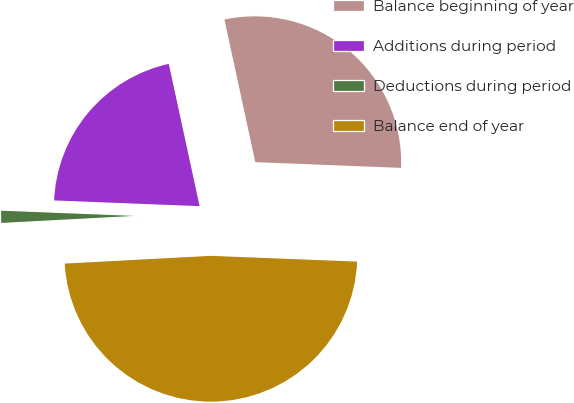Convert chart to OTSL. <chart><loc_0><loc_0><loc_500><loc_500><pie_chart><fcel>Balance beginning of year<fcel>Additions during period<fcel>Deductions during period<fcel>Balance end of year<nl><fcel>29.02%<fcel>20.98%<fcel>1.47%<fcel>48.53%<nl></chart> 